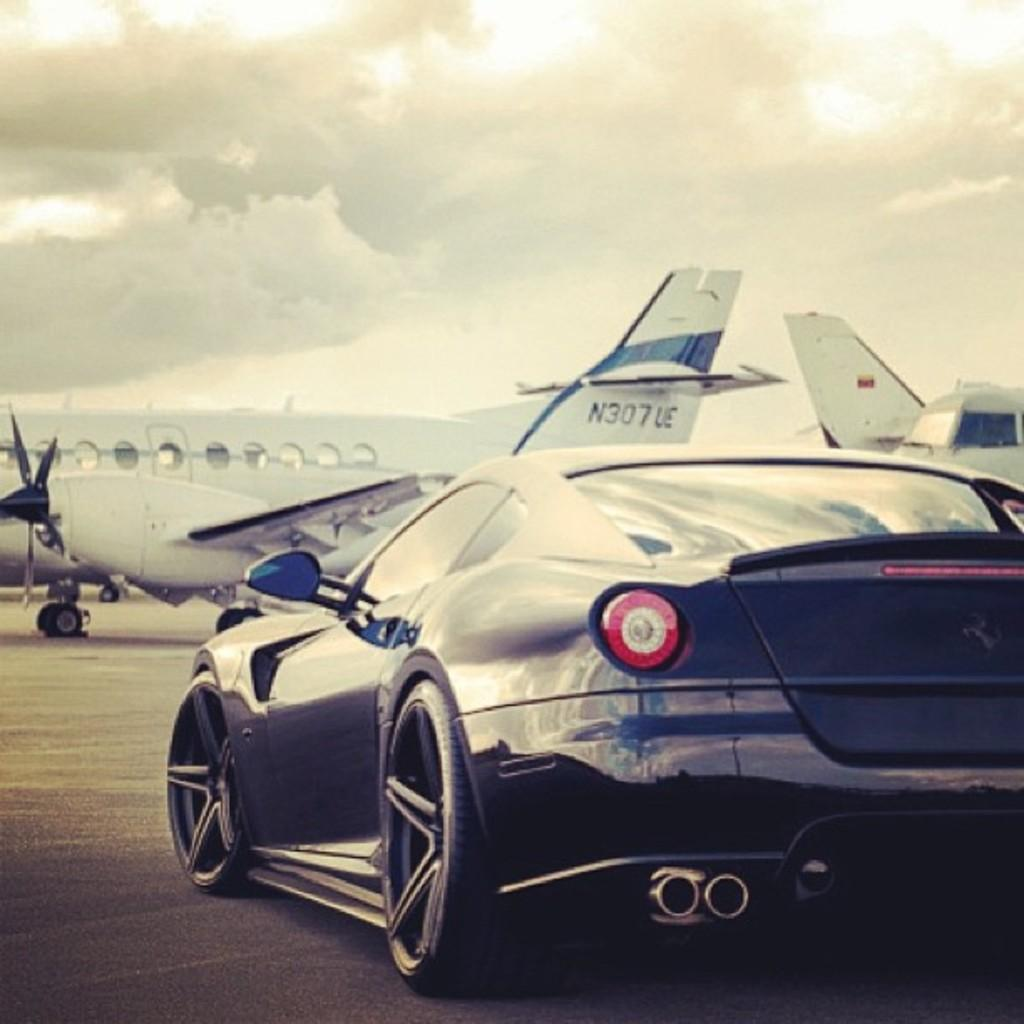<image>
Describe the image concisely. A black Lamborghini is parked by a private plane with the number N307 UE on the tail. 